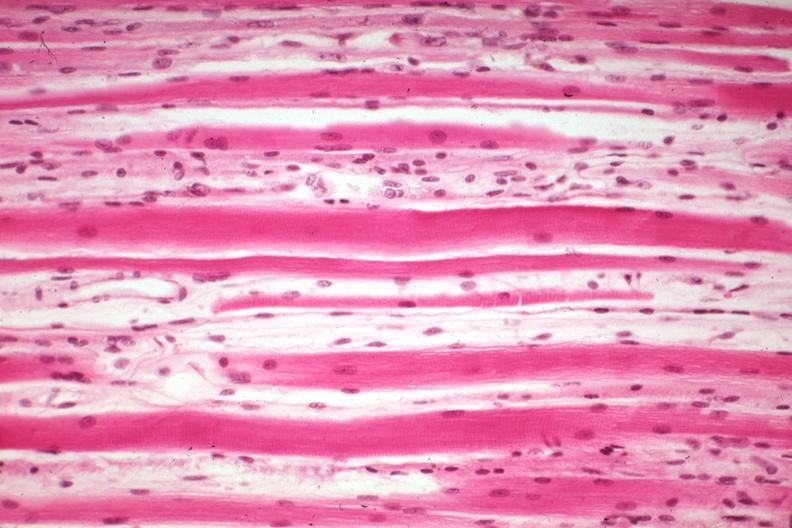what is high excellent steroid induced?
Answer the question using a single word or phrase. Atrophy 